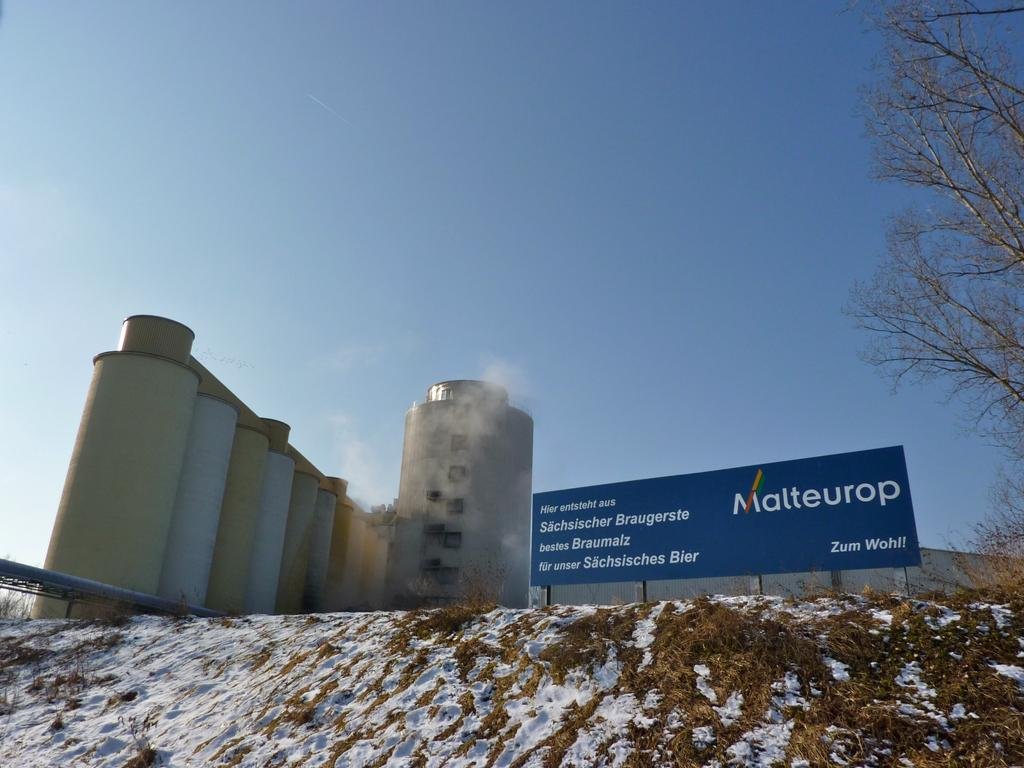<image>
Share a concise interpretation of the image provided. a sign for Malteurop is in front of some agricultural silos 